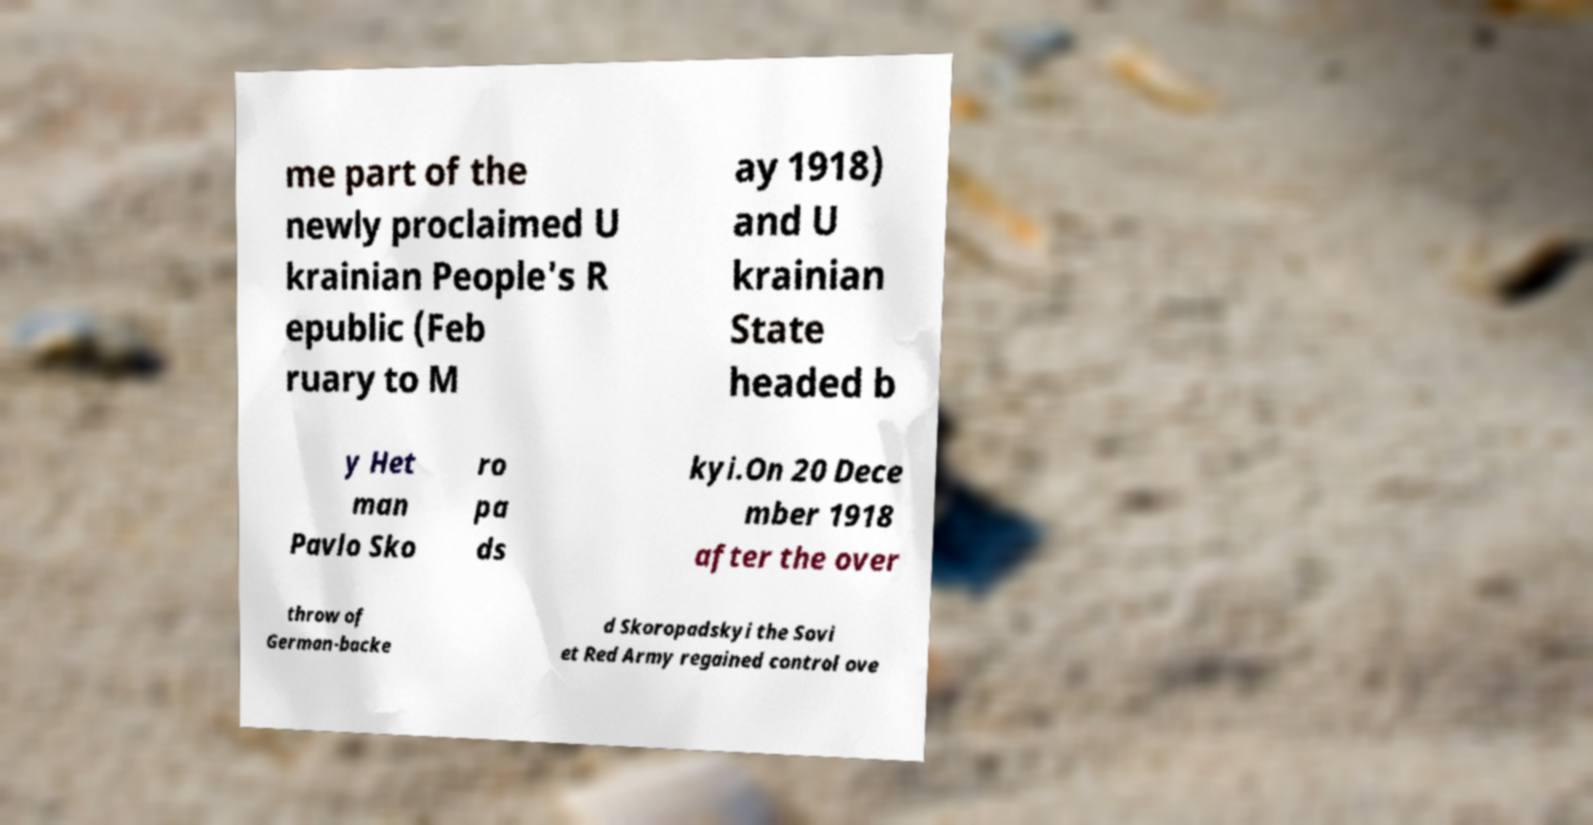For documentation purposes, I need the text within this image transcribed. Could you provide that? me part of the newly proclaimed U krainian People's R epublic (Feb ruary to M ay 1918) and U krainian State headed b y Het man Pavlo Sko ro pa ds kyi.On 20 Dece mber 1918 after the over throw of German-backe d Skoropadskyi the Sovi et Red Army regained control ove 